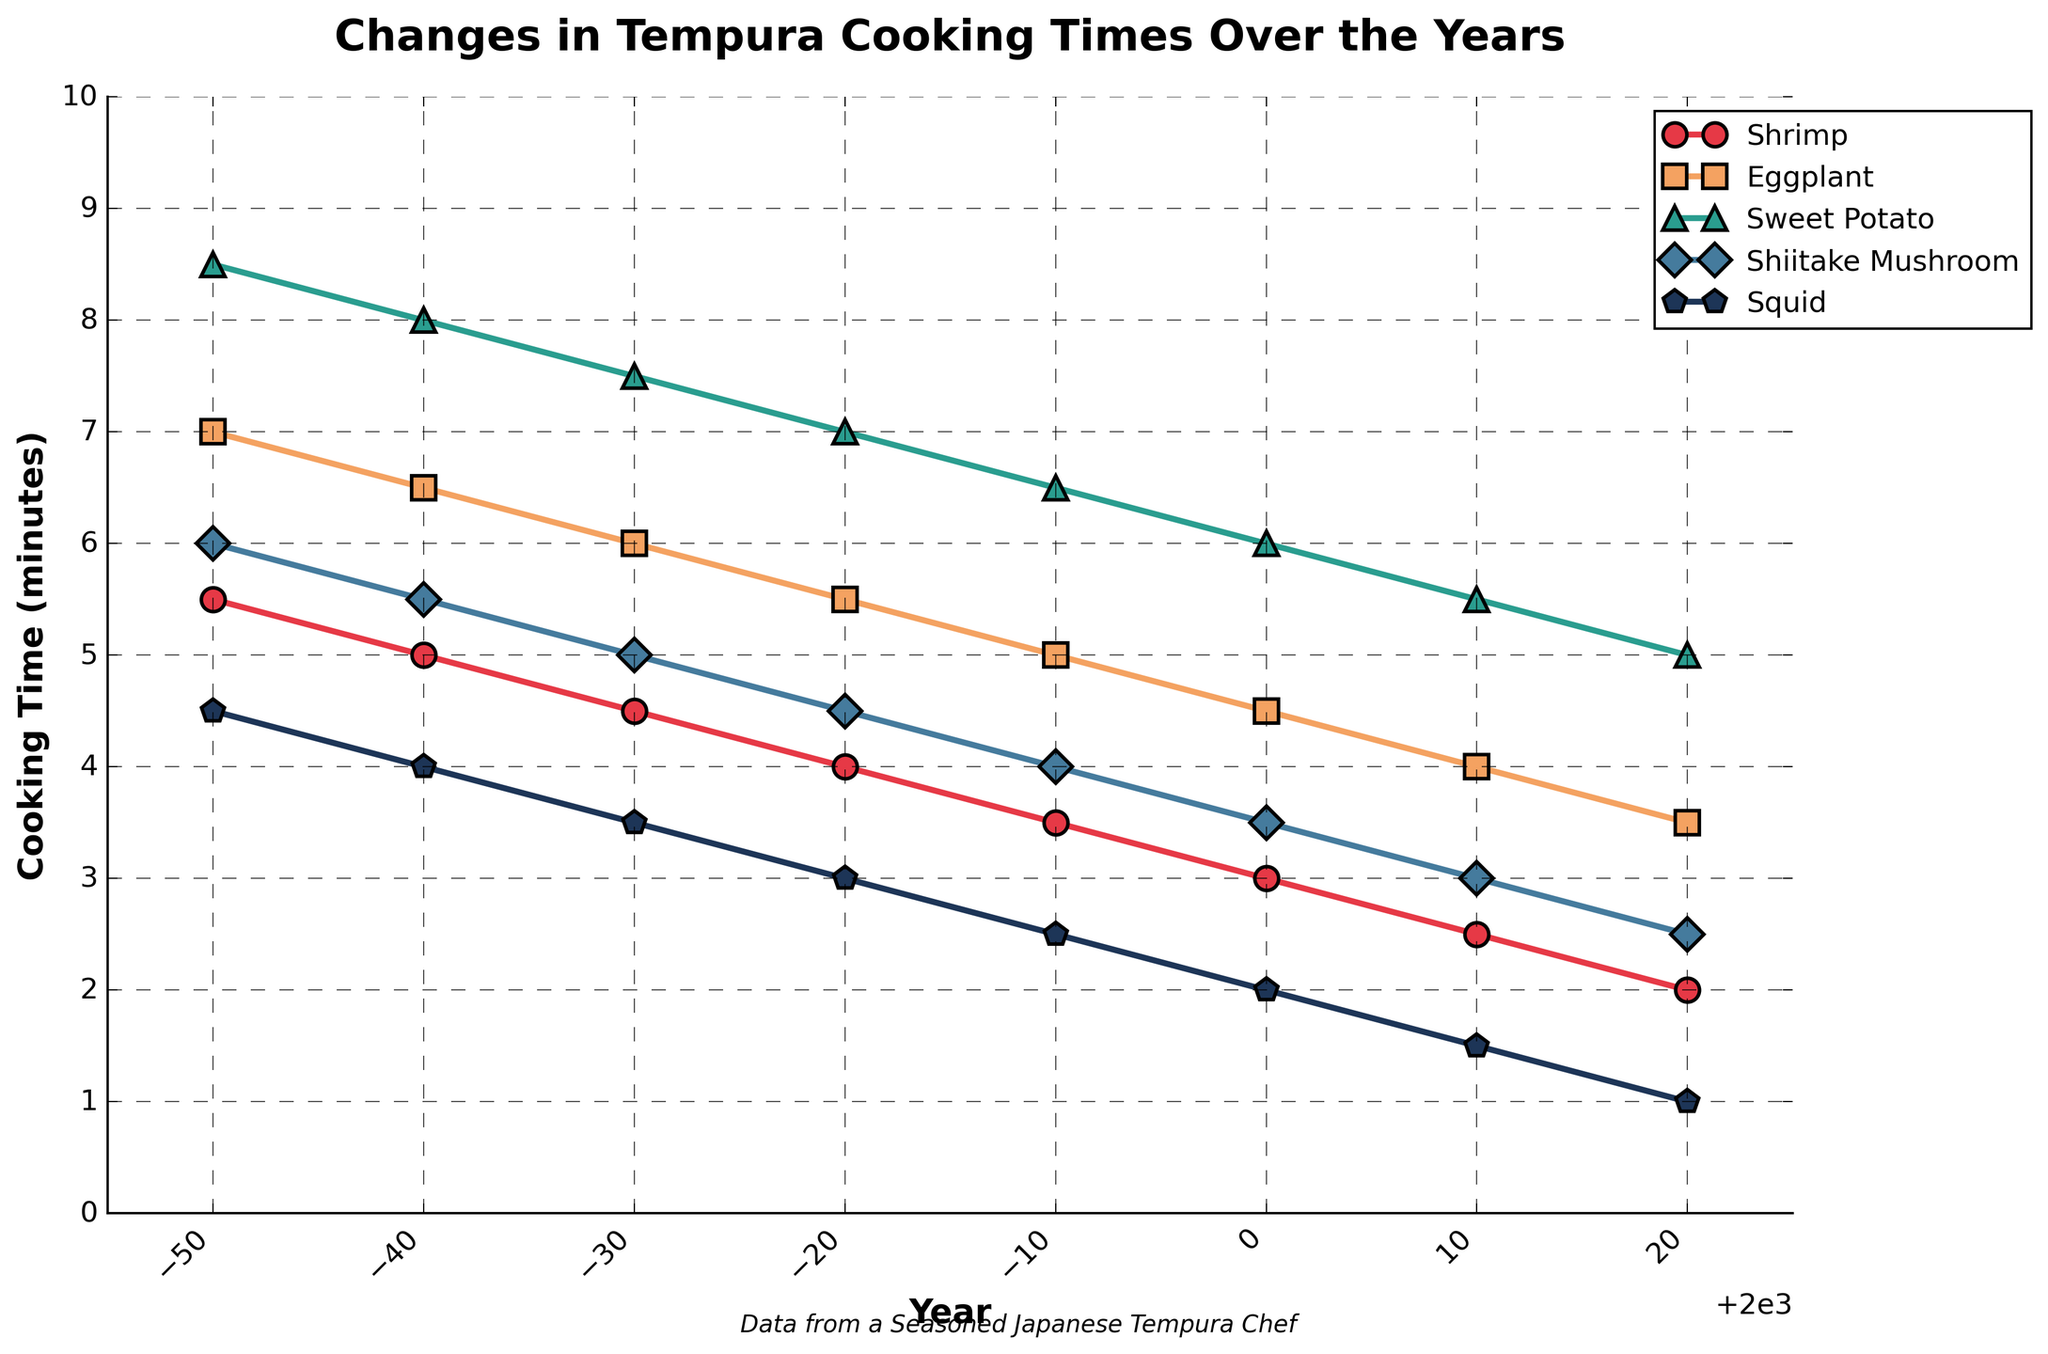What is the cooking time for Eggplant in 1980? To find the cooking time, locate the year 1980 on the x-axis and then read the value for Eggplant from the corresponding point on the graph.
Answer: 5.5 minutes Which tempura item had the shortest cooking time in 1960? In the year 1960, compare the cooking times for all tempura items and find the smallest value on the y-axis.
Answer: Squid How has the cooking time for Sweet Potato changed from 1950 to 2020? To determine the change in cooking time, find the cooking times for Sweet Potato in 1950 and 2020 and calculate the difference: 8.5 (1950) - 5.0 (2020) = 3.5 minutes decrease.
Answer: Decreased by 3.5 minutes What was the average cooking time for Shiitake Mushroom across all recorded years? Sum the cooking times for Shiitake Mushroom from 1950 to 2020, then divide by the number of years: (6.0 + 5.5 + 5.0 + 4.5 + 4.0 + 3.5 + 3.0 + 2.5)/8 = 4.5 minutes.
Answer: 4.5 minutes Between which two consecutive decades did Shrimp experience the largest decrease in cooking time? Calculate the cooking time differences between consecutive decades for Shrimp and identify the largest decrease:
1960-1950: 5.5 - 5.0 = 0.5
1970-1960: 5.0 - 4.5 = 0.5
1980-1970: 4.5 - 4.0 = 0.5
1990-1980: 4.0 - 3.5 = 0.5
2000-1990: 3.5 - 3.0 = 0.5
2010-2000: 3.0 - 2.5 = 0.5
2020-2010: 2.5 - 2.0 = 0.5
Since all differences are equal, any pair of decades will be a correct answer.
Answer: Any decades (e.g., 1950 to 1960) Which tempura item showed the most consistent cooking time decrease over the years? Evaluate the trends of all items to see which one has a uniform decline without any fluctuations from 1950 to 2020.
Answer: Sweet Potato How many minutes did the cooking time for Squid drop from the beginning to the end of the timeline? The difference in cooking time from 1950 to 2020 for Squid can be calculated as 4.5 (1950) - 1.0 (2020) = 3.5 minutes.
Answer: 3.5 minutes 